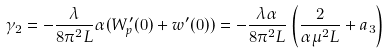Convert formula to latex. <formula><loc_0><loc_0><loc_500><loc_500>\gamma _ { 2 } = - \frac { \lambda } { 8 \pi ^ { 2 } L } \alpha ( W _ { p } ^ { \prime } ( 0 ) + w ^ { \prime } ( 0 ) ) = - \frac { \lambda \alpha } { 8 \pi ^ { 2 } L } \left ( \frac { 2 } { \alpha \mu ^ { 2 } L } + a _ { 3 } \right )</formula> 